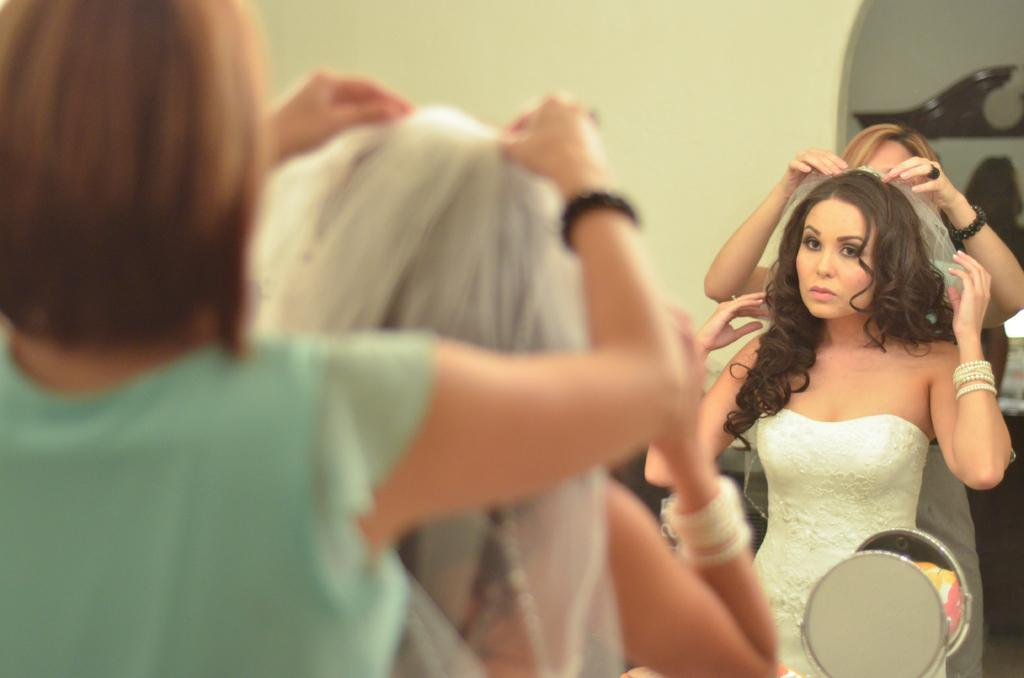How many people are in the image? There are two women in the image. Where are the women located in the image? The women are on a path in the image. What object is present in front of the women? There is a mirror in front of the women. What does the mirror reflect in the image? The mirror reflects the women and a wall in the image. What type of hope can be seen growing on the wall in the image? There is no mention of hope or any plant life in the image; it features two women on a path with a mirror reflecting them and a wall. 